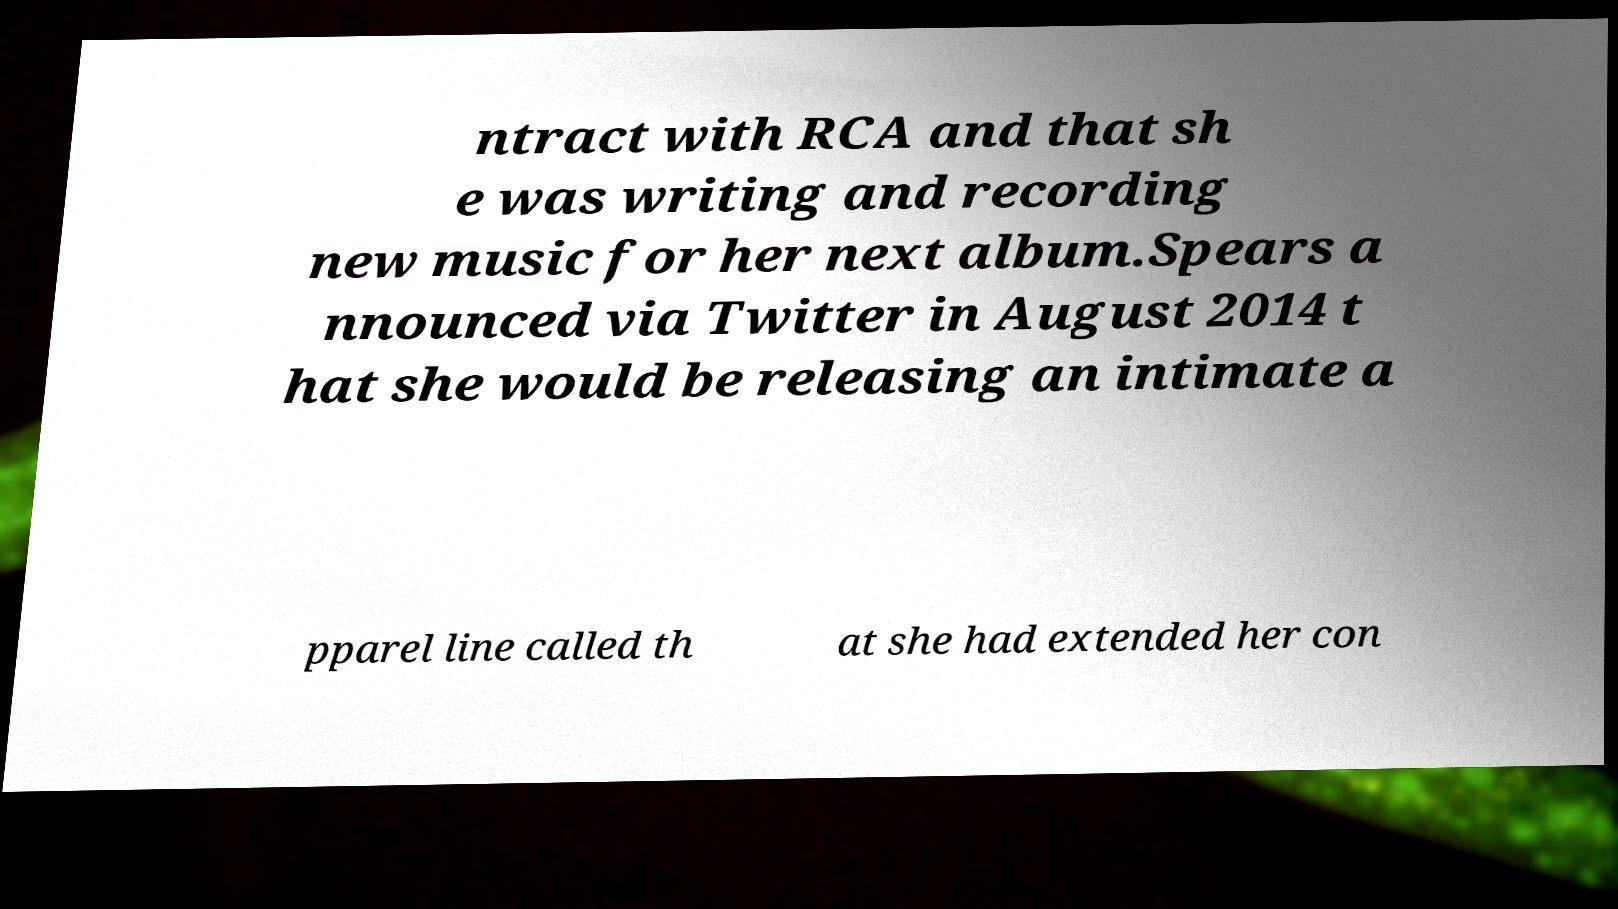I need the written content from this picture converted into text. Can you do that? ntract with RCA and that sh e was writing and recording new music for her next album.Spears a nnounced via Twitter in August 2014 t hat she would be releasing an intimate a pparel line called th at she had extended her con 